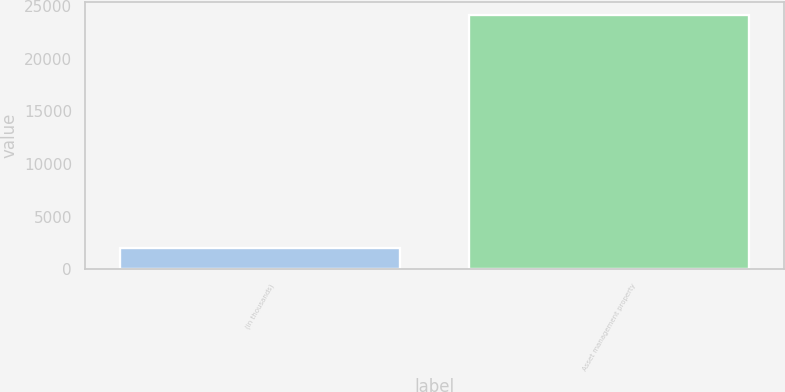<chart> <loc_0><loc_0><loc_500><loc_500><bar_chart><fcel>(in thousands)<fcel>Asset management property<nl><fcel>2013<fcel>24153<nl></chart> 